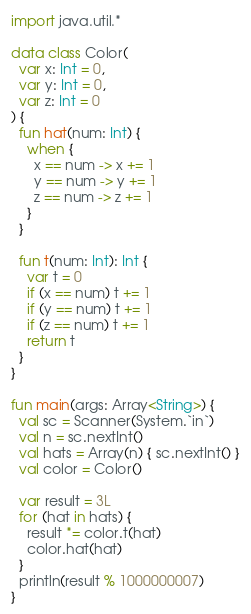Convert code to text. <code><loc_0><loc_0><loc_500><loc_500><_Kotlin_>import java.util.*

data class Color(
  var x: Int = 0,
  var y: Int = 0,
  var z: Int = 0
) {
  fun hat(num: Int) {
    when {
      x == num -> x += 1
      y == num -> y += 1
      z == num -> z += 1
    }
  }

  fun t(num: Int): Int {
    var t = 0
    if (x == num) t += 1
    if (y == num) t += 1
    if (z == num) t += 1
    return t
  }
}

fun main(args: Array<String>) {
  val sc = Scanner(System.`in`)
  val n = sc.nextInt()
  val hats = Array(n) { sc.nextInt() }
  val color = Color()

  var result = 3L
  for (hat in hats) {
    result *= color.t(hat)
    color.hat(hat)
  }
  println(result % 1000000007)
}</code> 